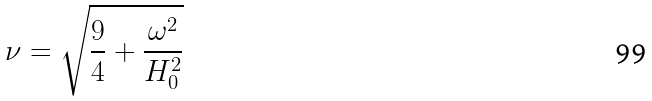Convert formula to latex. <formula><loc_0><loc_0><loc_500><loc_500>\nu = \sqrt { \frac { 9 } { 4 } + \frac { \omega ^ { 2 } } { H _ { 0 } ^ { 2 } } }</formula> 